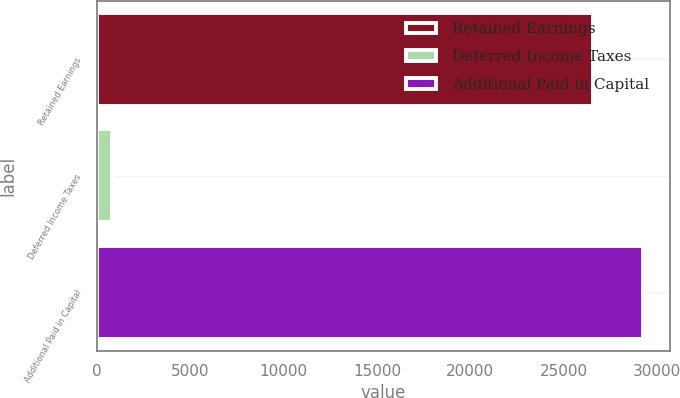Convert chart. <chart><loc_0><loc_0><loc_500><loc_500><bar_chart><fcel>Retained Earnings<fcel>Deferred Income Taxes<fcel>Additional Paid in Capital<nl><fcel>26584<fcel>838<fcel>29242.4<nl></chart> 